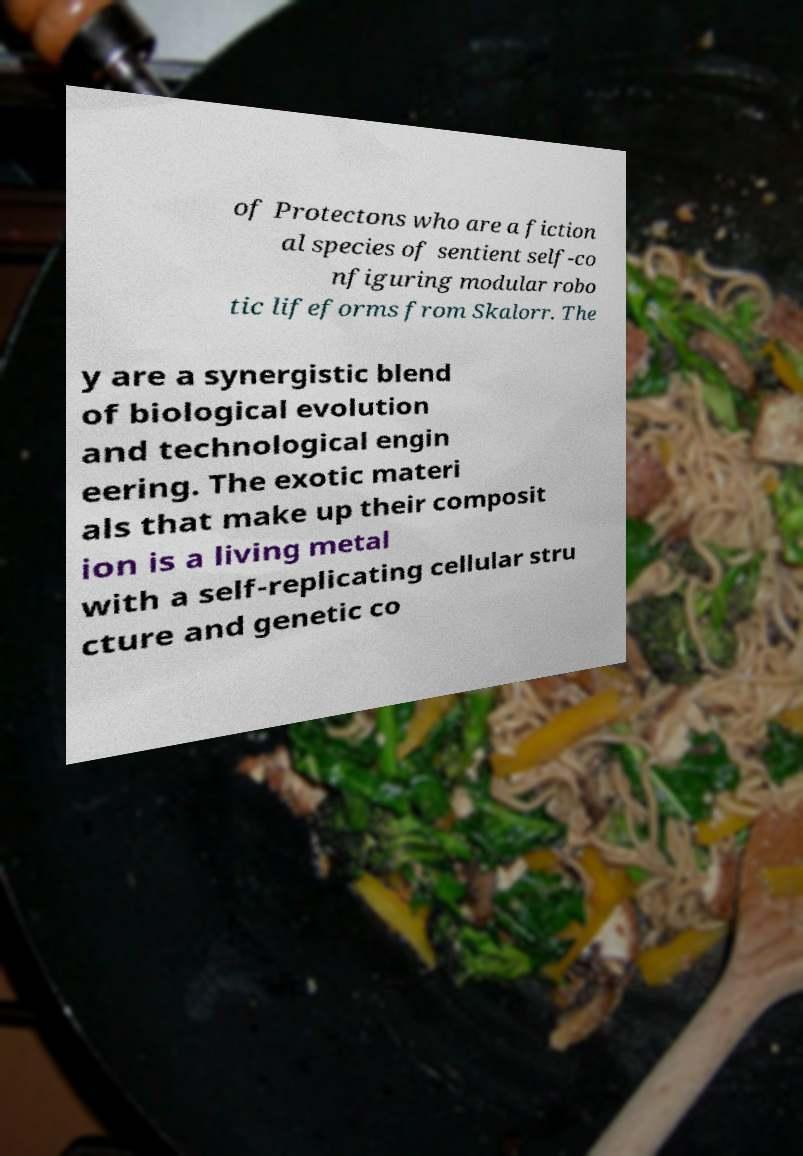Can you read and provide the text displayed in the image?This photo seems to have some interesting text. Can you extract and type it out for me? of Protectons who are a fiction al species of sentient self-co nfiguring modular robo tic lifeforms from Skalorr. The y are a synergistic blend of biological evolution and technological engin eering. The exotic materi als that make up their composit ion is a living metal with a self-replicating cellular stru cture and genetic co 